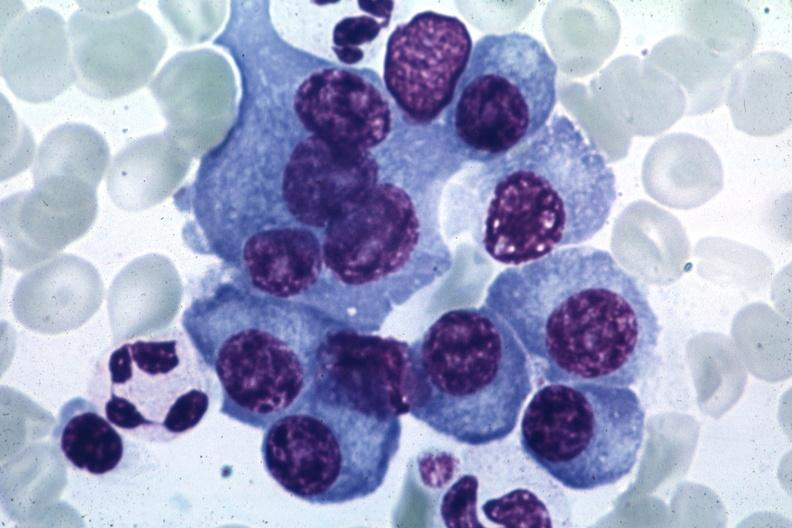does opened muscle show typical cells with some pleomorphism suspicious for multiple myeloma source unknown?
Answer the question using a single word or phrase. No 